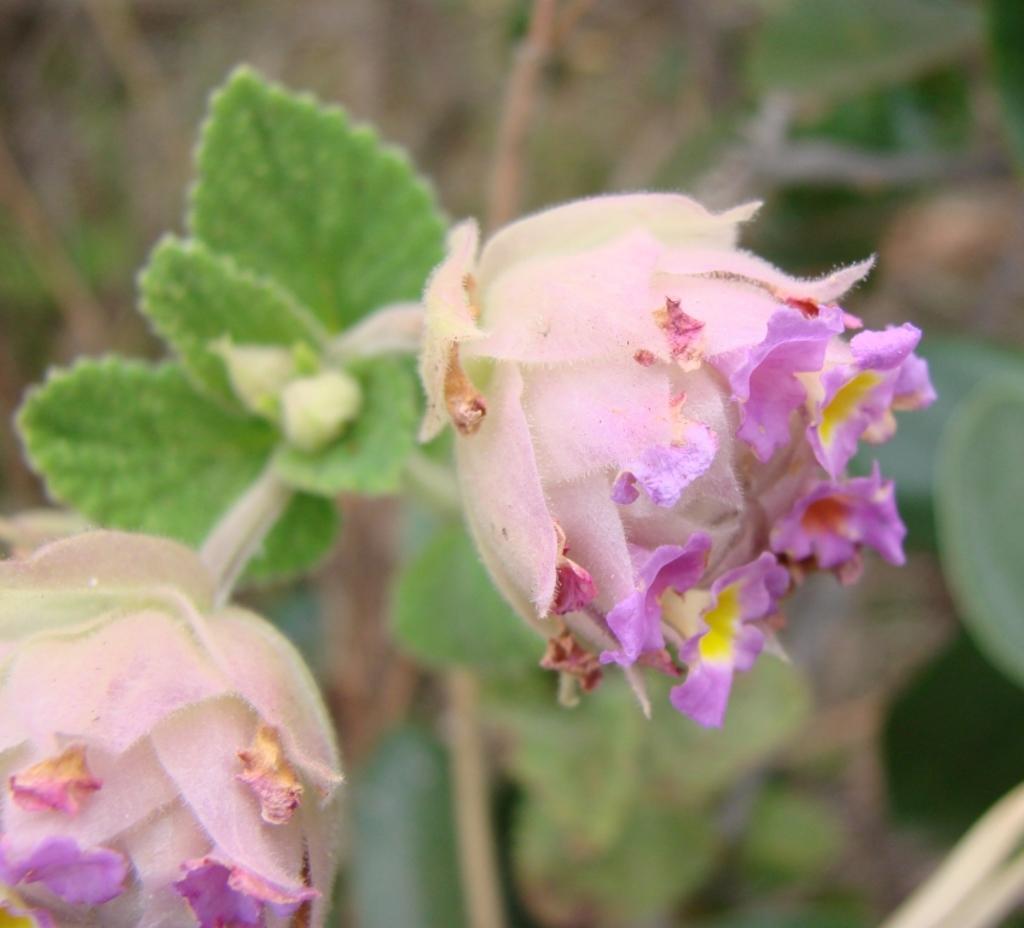How would you summarize this image in a sentence or two? This image consists of two flowers in pink and purple color along with the green leaves. At the bottom, there are plants. The background is blurred. 